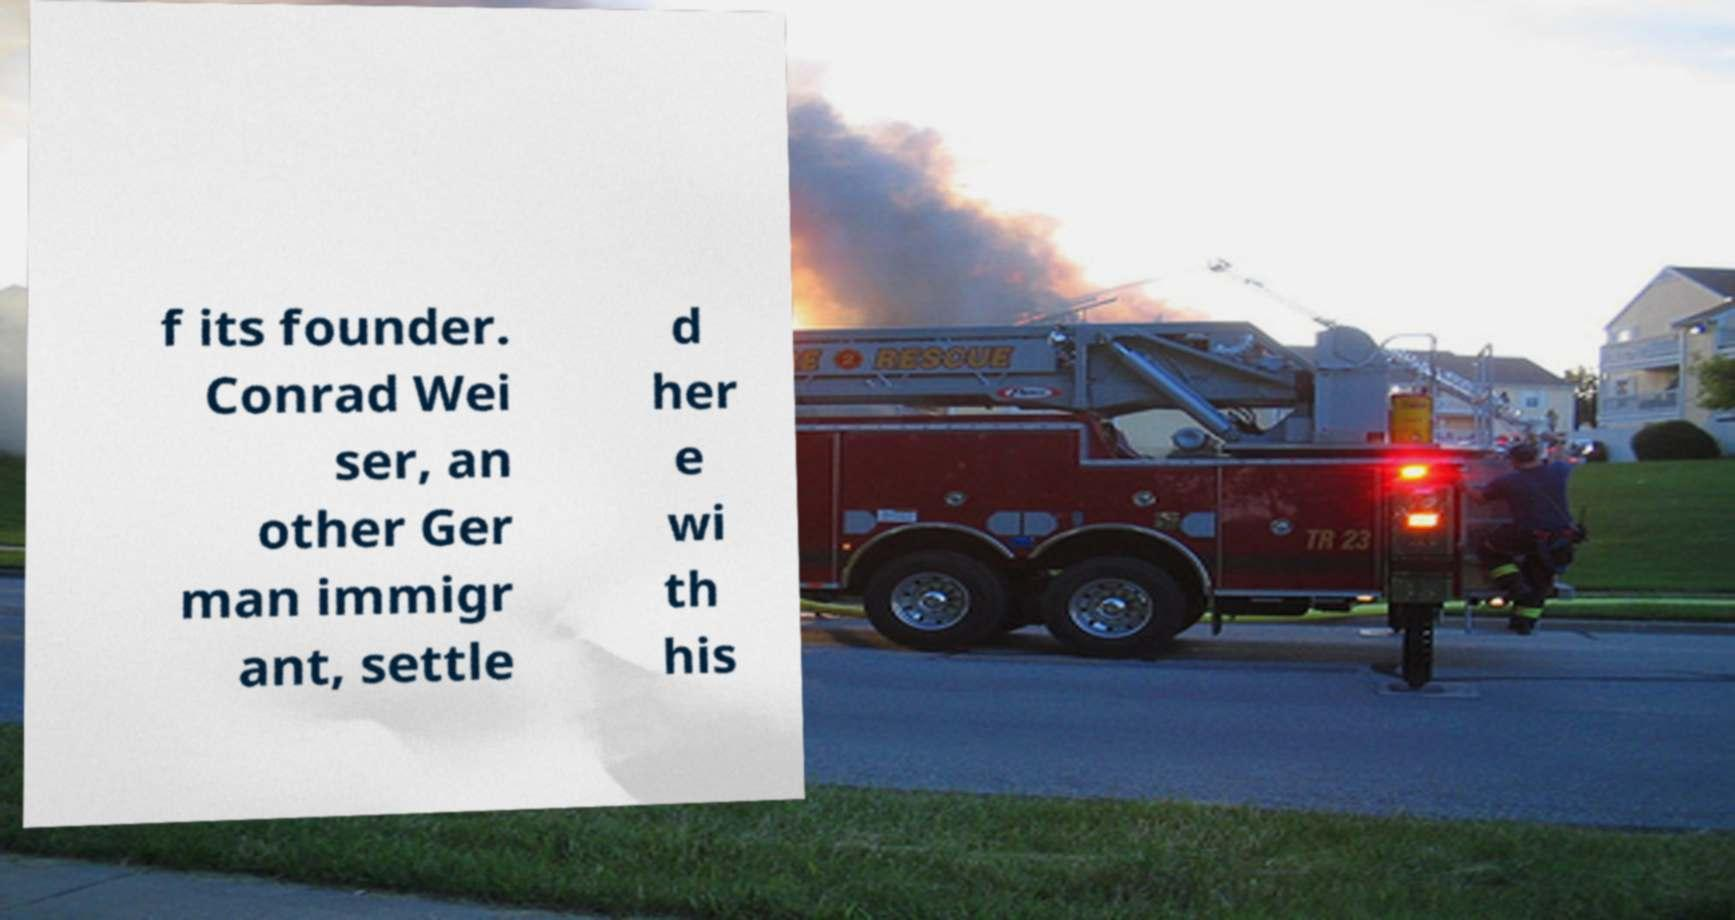Can you accurately transcribe the text from the provided image for me? f its founder. Conrad Wei ser, an other Ger man immigr ant, settle d her e wi th his 